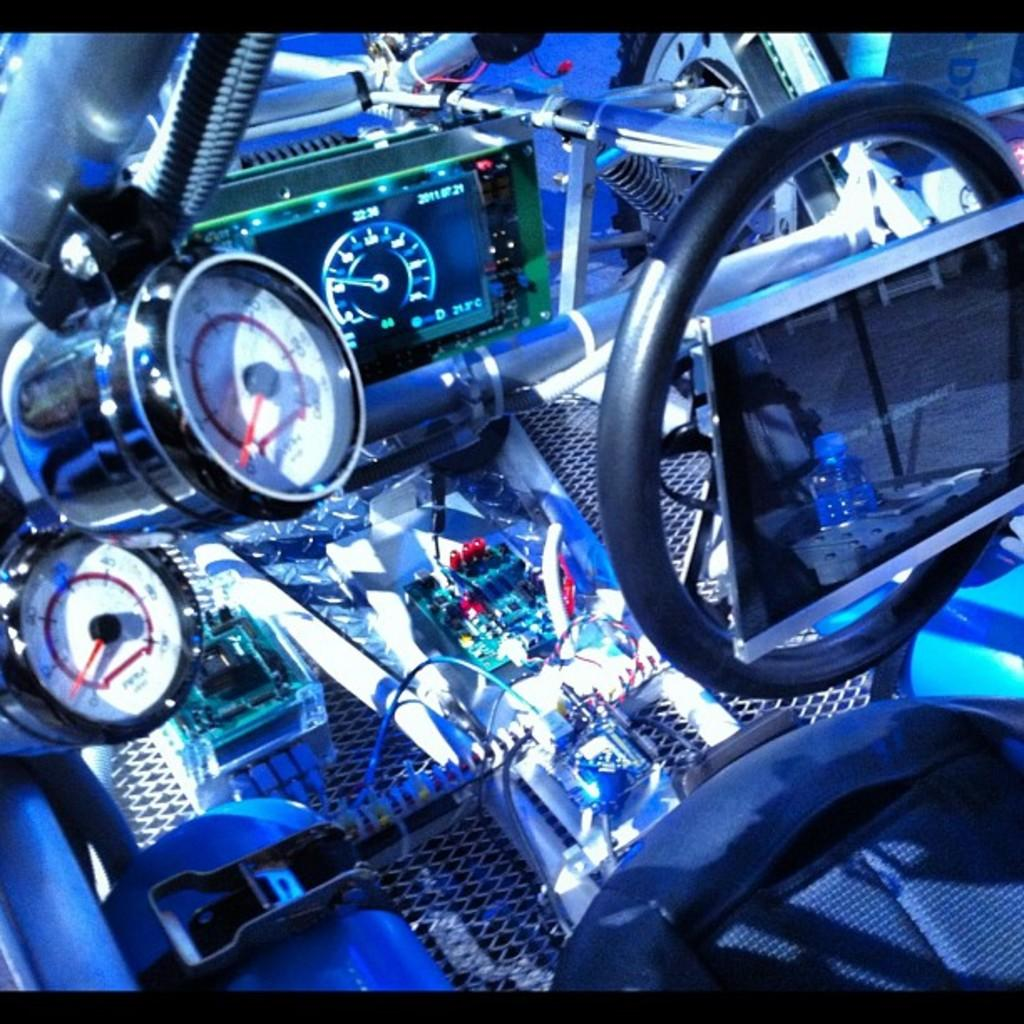What is the primary object in the image? There is a steering wheel in the image. What else can be seen in the image? There is a seat and meters in the image. Is there any other item visible in the image? Yes, there is a bottle in the image. Can you describe the unspecified objects in the image? Unfortunately, the facts provided do not specify the nature of the unspecified objects. How many icicles are hanging from the steering wheel in the image? There are no icicles present in the image. What type of ray is visible in the image? There is no ray visible in the image. 